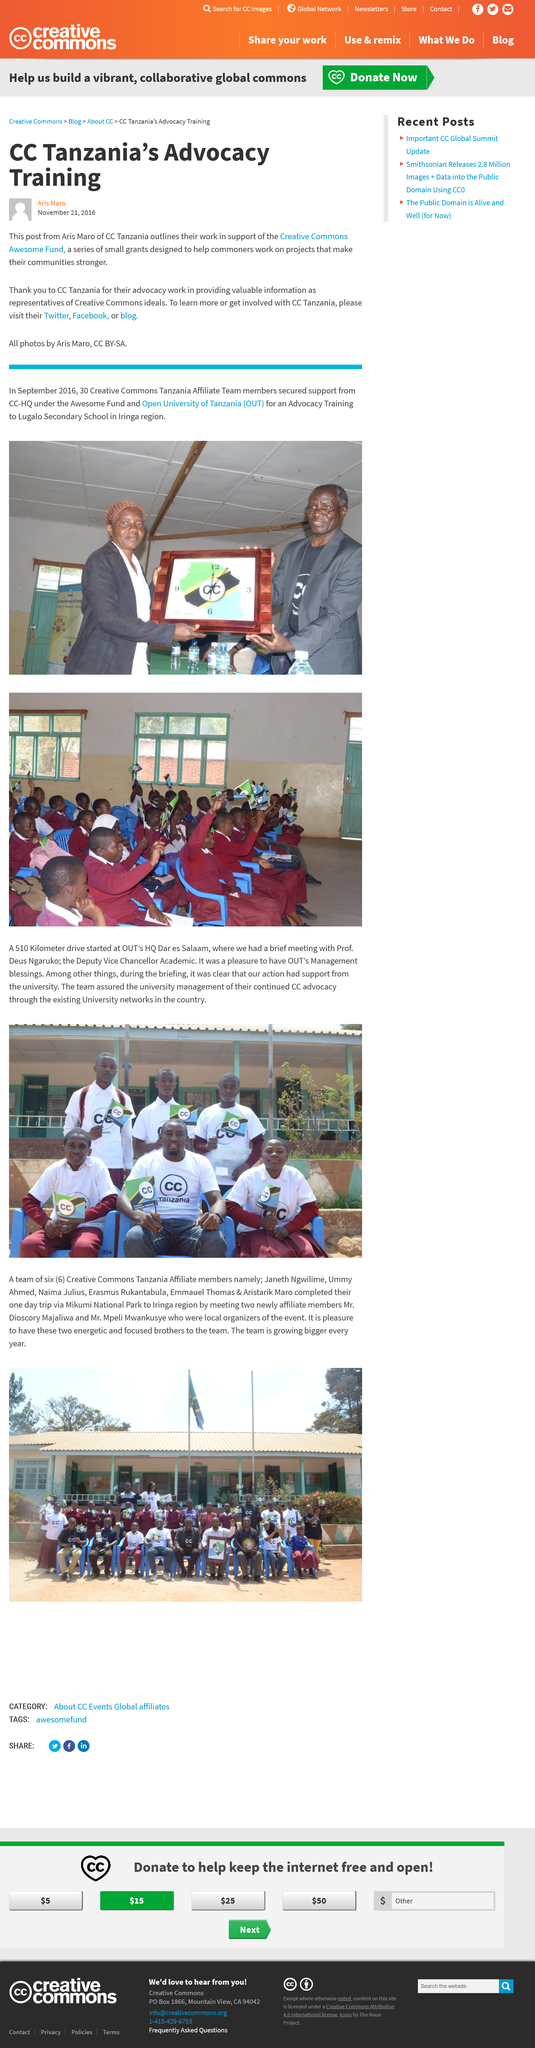Indicate a few pertinent items in this graphic. The Creative Commons Tanzania Affiliate Team received support from CC-HQ for advocacy training and is recognized as seen in the clock image. It is possible to become involved with CC Tanzania by visiting their blog. Yes, CC Tanzania supports the Creative Commons Awesome Fund. The CC Tanzania Affiliate Team obtained funding from CC-HQ in September 2016. On November 21, 2016, Aris Maro wrote a post about CC Tanzania. 